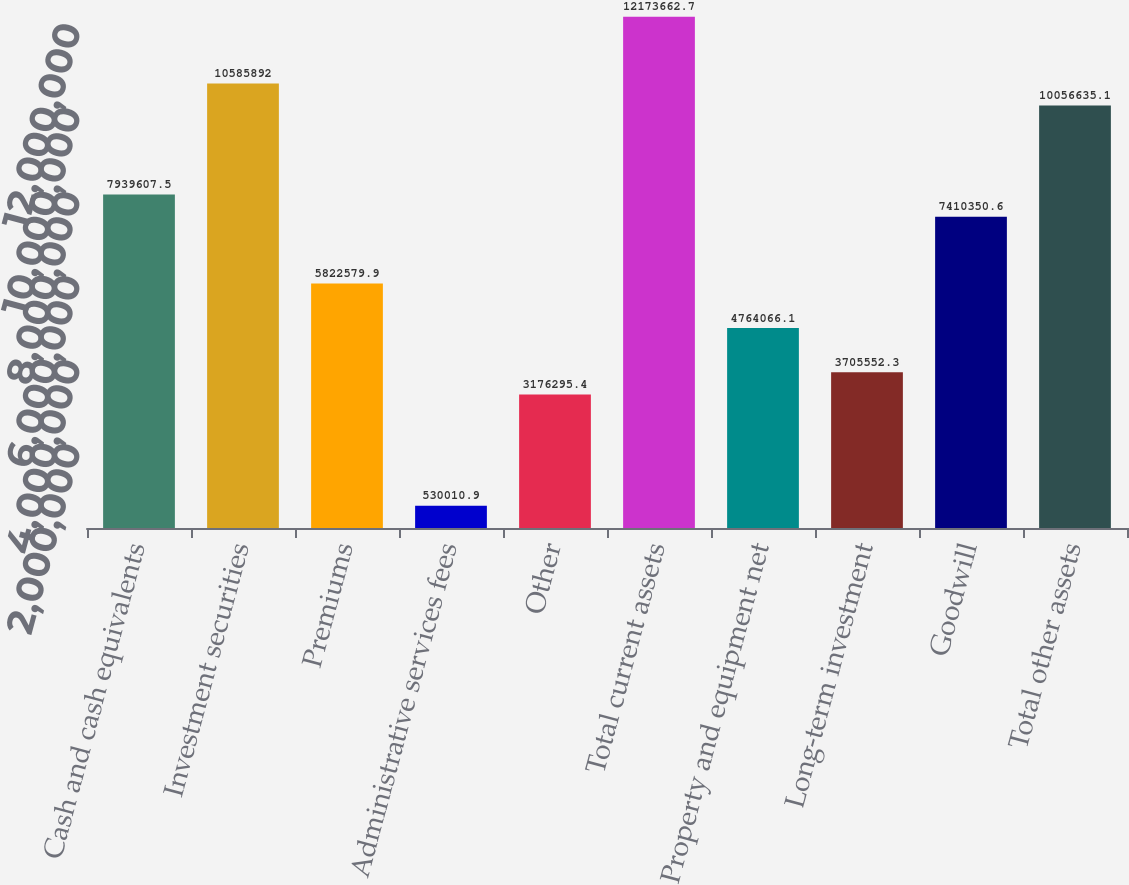Convert chart to OTSL. <chart><loc_0><loc_0><loc_500><loc_500><bar_chart><fcel>Cash and cash equivalents<fcel>Investment securities<fcel>Premiums<fcel>Administrative services fees<fcel>Other<fcel>Total current assets<fcel>Property and equipment net<fcel>Long-term investment<fcel>Goodwill<fcel>Total other assets<nl><fcel>7.93961e+06<fcel>1.05859e+07<fcel>5.82258e+06<fcel>530011<fcel>3.1763e+06<fcel>1.21737e+07<fcel>4.76407e+06<fcel>3.70555e+06<fcel>7.41035e+06<fcel>1.00566e+07<nl></chart> 